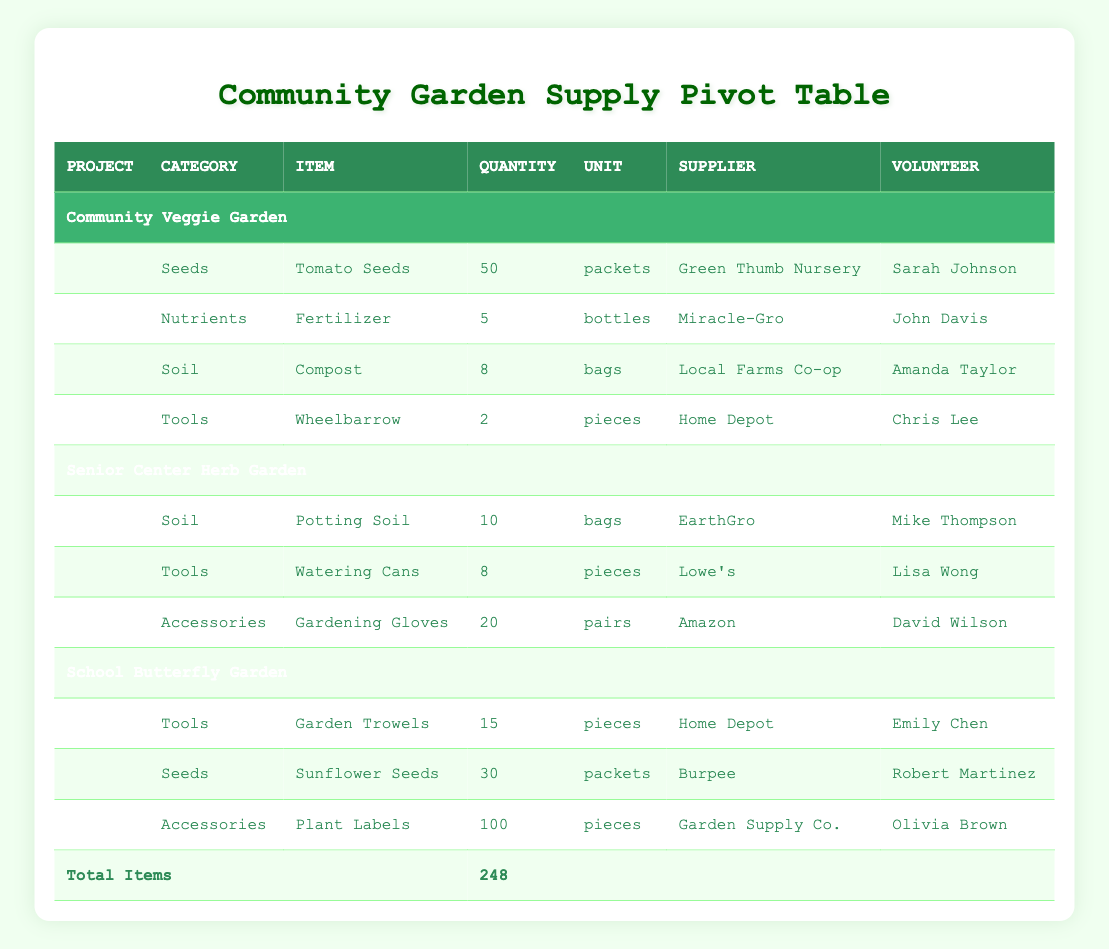What is the total quantity of Gardening Gloves allocated for the Senior Center Herb Garden? There is only one entry for Gardening Gloves under the Senior Center Herb Garden project with a quantity of 20 pairs listed.
Answer: 20 pairs Who supplied the Fertilizer used in the Community Veggie Garden? In the Community Veggie Garden section, the Fertilizer was supplied by Miracle-Gro.
Answer: Miracle-Gro How many different types of tools are listed in total across all projects? In the Tools category, there are three types listed: Garden Trowels, Watering Cans, and Wheelbarrow. Thus, there are a total of 3 different types of tools.
Answer: 3 Is Compositing included as a supply category for any project? Yes, Compost is listed under the Soil category for the Community Veggie Garden.
Answer: Yes What is the total number of items used in the Community Veggie Garden? The total quantity for items in the Community Veggie Garden includes: 50 Tomato Seeds, 5 Fertilizer bottles, 8 Compost bags, and 2 Wheelbarrows. Therefore, the total is 50 + 5 + 8 + 2 = 65.
Answer: 65 